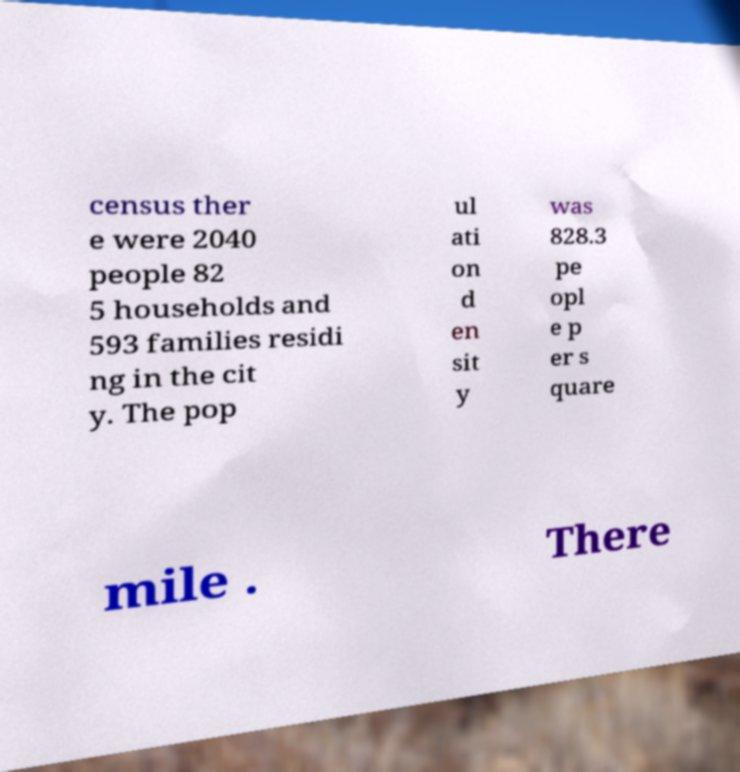Could you extract and type out the text from this image? census ther e were 2040 people 82 5 households and 593 families residi ng in the cit y. The pop ul ati on d en sit y was 828.3 pe opl e p er s quare mile . There 